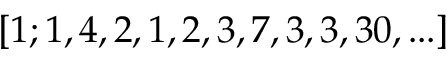Convert formula to latex. <formula><loc_0><loc_0><loc_500><loc_500>[ 1 ; 1 , 4 , 2 , 1 , 2 , 3 , 7 , 3 , 3 , 3 0 , \dots ]</formula> 